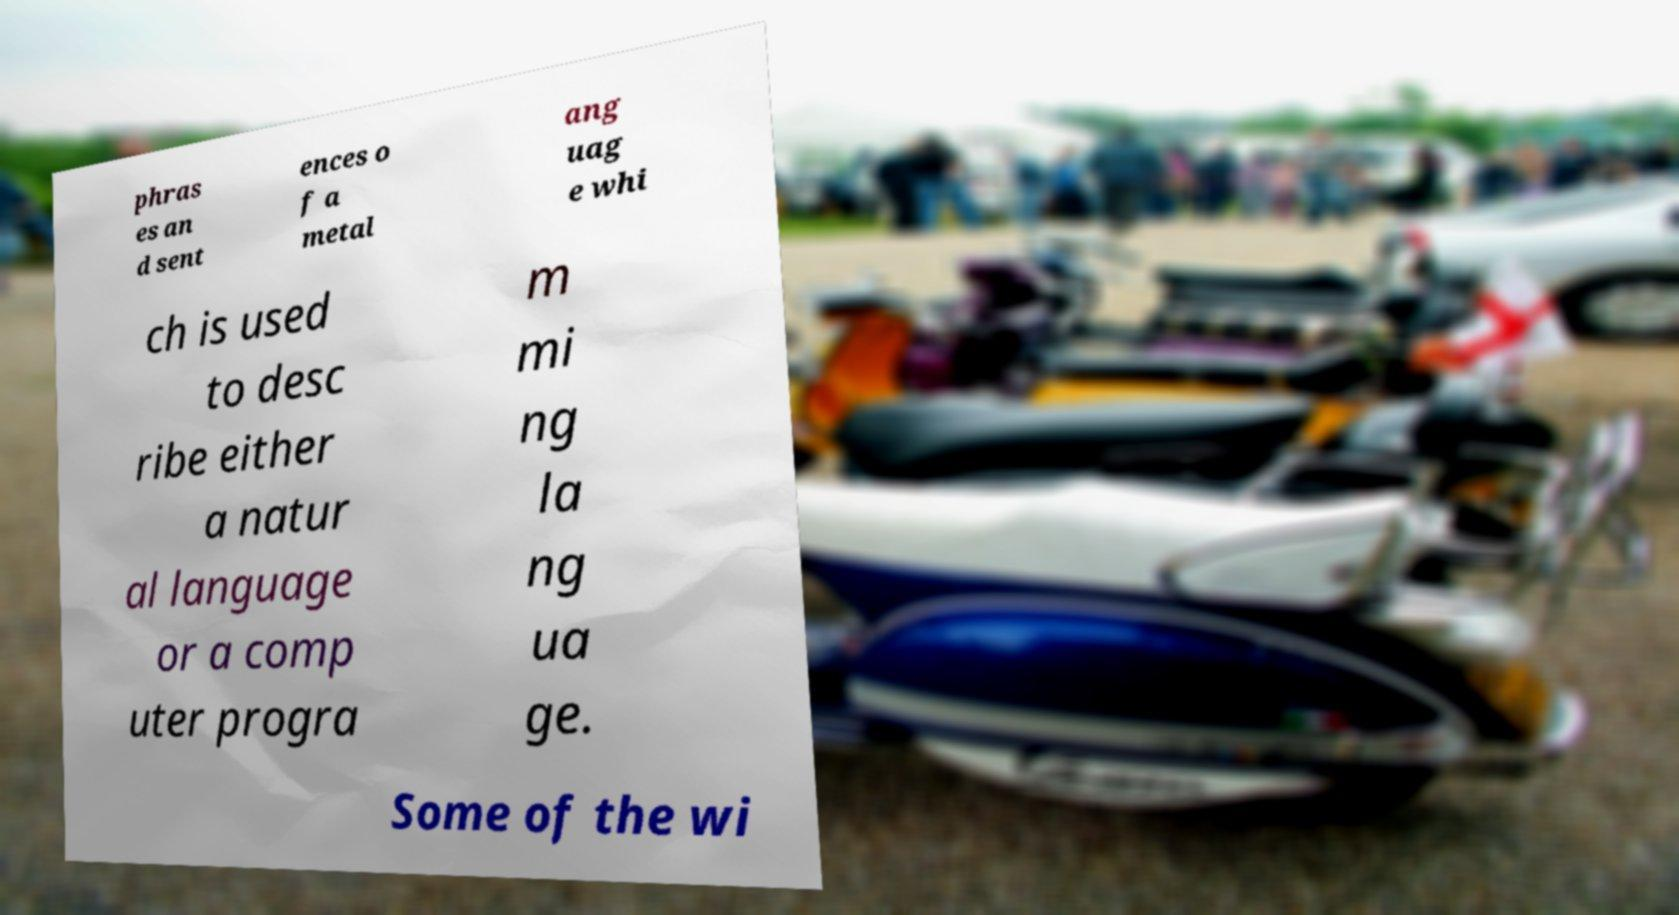What messages or text are displayed in this image? I need them in a readable, typed format. phras es an d sent ences o f a metal ang uag e whi ch is used to desc ribe either a natur al language or a comp uter progra m mi ng la ng ua ge. Some of the wi 